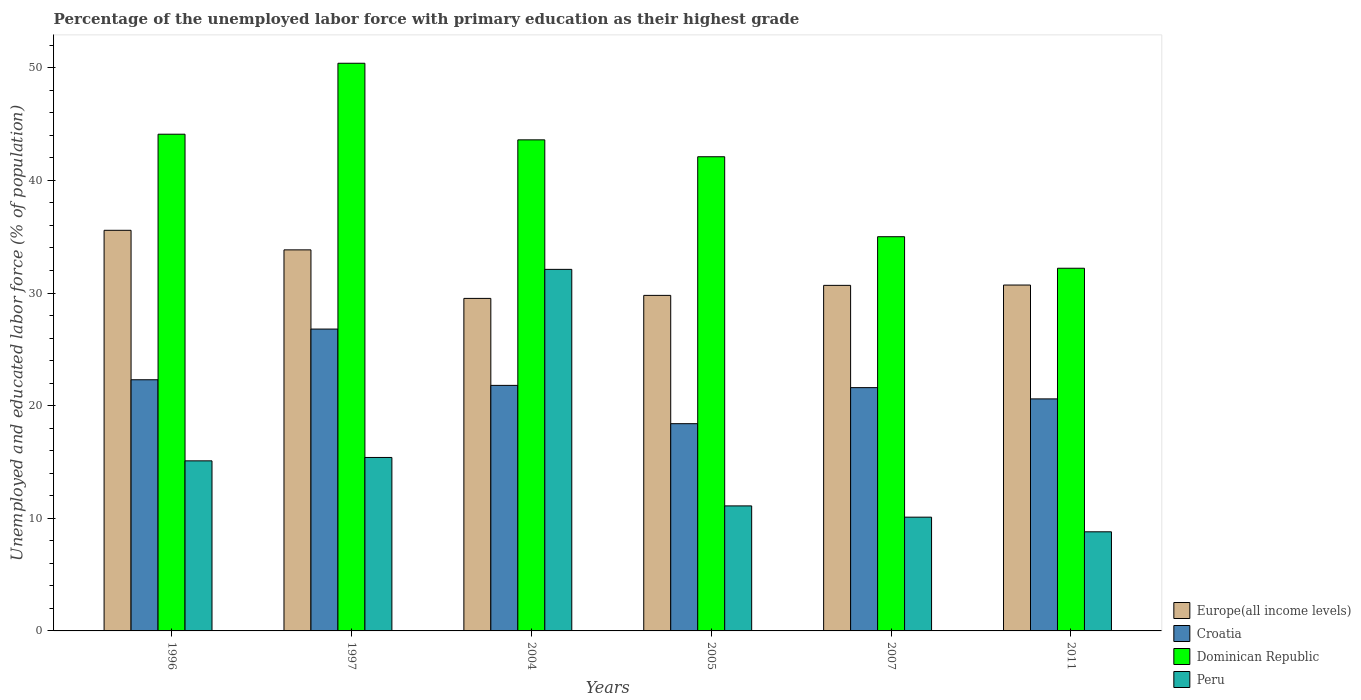How many different coloured bars are there?
Provide a succinct answer. 4. Are the number of bars on each tick of the X-axis equal?
Your response must be concise. Yes. How many bars are there on the 3rd tick from the left?
Your response must be concise. 4. What is the label of the 5th group of bars from the left?
Your answer should be very brief. 2007. Across all years, what is the maximum percentage of the unemployed labor force with primary education in Peru?
Your response must be concise. 32.1. Across all years, what is the minimum percentage of the unemployed labor force with primary education in Dominican Republic?
Provide a short and direct response. 32.2. In which year was the percentage of the unemployed labor force with primary education in Europe(all income levels) minimum?
Provide a succinct answer. 2004. What is the total percentage of the unemployed labor force with primary education in Croatia in the graph?
Your answer should be very brief. 131.5. What is the difference between the percentage of the unemployed labor force with primary education in Croatia in 1996 and that in 1997?
Ensure brevity in your answer.  -4.5. What is the difference between the percentage of the unemployed labor force with primary education in Croatia in 2011 and the percentage of the unemployed labor force with primary education in Peru in 2005?
Provide a succinct answer. 9.5. What is the average percentage of the unemployed labor force with primary education in Peru per year?
Ensure brevity in your answer.  15.43. In the year 1997, what is the difference between the percentage of the unemployed labor force with primary education in Europe(all income levels) and percentage of the unemployed labor force with primary education in Dominican Republic?
Offer a very short reply. -16.57. In how many years, is the percentage of the unemployed labor force with primary education in Europe(all income levels) greater than 30 %?
Offer a terse response. 4. What is the ratio of the percentage of the unemployed labor force with primary education in Europe(all income levels) in 2004 to that in 2005?
Make the answer very short. 0.99. Is the percentage of the unemployed labor force with primary education in Europe(all income levels) in 1996 less than that in 2011?
Provide a short and direct response. No. What is the difference between the highest and the lowest percentage of the unemployed labor force with primary education in Dominican Republic?
Ensure brevity in your answer.  18.2. In how many years, is the percentage of the unemployed labor force with primary education in Europe(all income levels) greater than the average percentage of the unemployed labor force with primary education in Europe(all income levels) taken over all years?
Keep it short and to the point. 2. Is it the case that in every year, the sum of the percentage of the unemployed labor force with primary education in Europe(all income levels) and percentage of the unemployed labor force with primary education in Peru is greater than the sum of percentage of the unemployed labor force with primary education in Croatia and percentage of the unemployed labor force with primary education in Dominican Republic?
Offer a very short reply. No. What does the 1st bar from the left in 2005 represents?
Make the answer very short. Europe(all income levels). What does the 4th bar from the right in 2004 represents?
Offer a terse response. Europe(all income levels). Are all the bars in the graph horizontal?
Keep it short and to the point. No. How many years are there in the graph?
Make the answer very short. 6. Where does the legend appear in the graph?
Your answer should be very brief. Bottom right. How many legend labels are there?
Ensure brevity in your answer.  4. How are the legend labels stacked?
Make the answer very short. Vertical. What is the title of the graph?
Provide a short and direct response. Percentage of the unemployed labor force with primary education as their highest grade. Does "India" appear as one of the legend labels in the graph?
Your response must be concise. No. What is the label or title of the Y-axis?
Your answer should be compact. Unemployed and educated labor force (% of population). What is the Unemployed and educated labor force (% of population) in Europe(all income levels) in 1996?
Offer a very short reply. 35.57. What is the Unemployed and educated labor force (% of population) in Croatia in 1996?
Your response must be concise. 22.3. What is the Unemployed and educated labor force (% of population) of Dominican Republic in 1996?
Provide a succinct answer. 44.1. What is the Unemployed and educated labor force (% of population) in Peru in 1996?
Offer a very short reply. 15.1. What is the Unemployed and educated labor force (% of population) of Europe(all income levels) in 1997?
Provide a short and direct response. 33.83. What is the Unemployed and educated labor force (% of population) in Croatia in 1997?
Your answer should be compact. 26.8. What is the Unemployed and educated labor force (% of population) in Dominican Republic in 1997?
Your answer should be compact. 50.4. What is the Unemployed and educated labor force (% of population) in Peru in 1997?
Make the answer very short. 15.4. What is the Unemployed and educated labor force (% of population) of Europe(all income levels) in 2004?
Offer a terse response. 29.52. What is the Unemployed and educated labor force (% of population) of Croatia in 2004?
Give a very brief answer. 21.8. What is the Unemployed and educated labor force (% of population) of Dominican Republic in 2004?
Provide a succinct answer. 43.6. What is the Unemployed and educated labor force (% of population) of Peru in 2004?
Make the answer very short. 32.1. What is the Unemployed and educated labor force (% of population) in Europe(all income levels) in 2005?
Ensure brevity in your answer.  29.79. What is the Unemployed and educated labor force (% of population) of Croatia in 2005?
Offer a terse response. 18.4. What is the Unemployed and educated labor force (% of population) of Dominican Republic in 2005?
Provide a short and direct response. 42.1. What is the Unemployed and educated labor force (% of population) in Peru in 2005?
Give a very brief answer. 11.1. What is the Unemployed and educated labor force (% of population) in Europe(all income levels) in 2007?
Offer a terse response. 30.68. What is the Unemployed and educated labor force (% of population) of Croatia in 2007?
Keep it short and to the point. 21.6. What is the Unemployed and educated labor force (% of population) in Peru in 2007?
Your answer should be compact. 10.1. What is the Unemployed and educated labor force (% of population) in Europe(all income levels) in 2011?
Offer a very short reply. 30.71. What is the Unemployed and educated labor force (% of population) in Croatia in 2011?
Ensure brevity in your answer.  20.6. What is the Unemployed and educated labor force (% of population) in Dominican Republic in 2011?
Offer a terse response. 32.2. What is the Unemployed and educated labor force (% of population) in Peru in 2011?
Offer a terse response. 8.8. Across all years, what is the maximum Unemployed and educated labor force (% of population) in Europe(all income levels)?
Provide a succinct answer. 35.57. Across all years, what is the maximum Unemployed and educated labor force (% of population) of Croatia?
Your response must be concise. 26.8. Across all years, what is the maximum Unemployed and educated labor force (% of population) in Dominican Republic?
Ensure brevity in your answer.  50.4. Across all years, what is the maximum Unemployed and educated labor force (% of population) in Peru?
Offer a terse response. 32.1. Across all years, what is the minimum Unemployed and educated labor force (% of population) in Europe(all income levels)?
Offer a terse response. 29.52. Across all years, what is the minimum Unemployed and educated labor force (% of population) of Croatia?
Provide a short and direct response. 18.4. Across all years, what is the minimum Unemployed and educated labor force (% of population) of Dominican Republic?
Keep it short and to the point. 32.2. Across all years, what is the minimum Unemployed and educated labor force (% of population) of Peru?
Make the answer very short. 8.8. What is the total Unemployed and educated labor force (% of population) in Europe(all income levels) in the graph?
Offer a very short reply. 190.1. What is the total Unemployed and educated labor force (% of population) in Croatia in the graph?
Provide a succinct answer. 131.5. What is the total Unemployed and educated labor force (% of population) of Dominican Republic in the graph?
Ensure brevity in your answer.  247.4. What is the total Unemployed and educated labor force (% of population) of Peru in the graph?
Ensure brevity in your answer.  92.6. What is the difference between the Unemployed and educated labor force (% of population) in Europe(all income levels) in 1996 and that in 1997?
Give a very brief answer. 1.74. What is the difference between the Unemployed and educated labor force (% of population) in Dominican Republic in 1996 and that in 1997?
Make the answer very short. -6.3. What is the difference between the Unemployed and educated labor force (% of population) of Europe(all income levels) in 1996 and that in 2004?
Your answer should be compact. 6.05. What is the difference between the Unemployed and educated labor force (% of population) in Croatia in 1996 and that in 2004?
Make the answer very short. 0.5. What is the difference between the Unemployed and educated labor force (% of population) of Peru in 1996 and that in 2004?
Your answer should be very brief. -17. What is the difference between the Unemployed and educated labor force (% of population) in Europe(all income levels) in 1996 and that in 2005?
Your response must be concise. 5.78. What is the difference between the Unemployed and educated labor force (% of population) of Dominican Republic in 1996 and that in 2005?
Provide a short and direct response. 2. What is the difference between the Unemployed and educated labor force (% of population) in Peru in 1996 and that in 2005?
Your answer should be very brief. 4. What is the difference between the Unemployed and educated labor force (% of population) of Europe(all income levels) in 1996 and that in 2007?
Your response must be concise. 4.89. What is the difference between the Unemployed and educated labor force (% of population) of Croatia in 1996 and that in 2007?
Make the answer very short. 0.7. What is the difference between the Unemployed and educated labor force (% of population) of Peru in 1996 and that in 2007?
Give a very brief answer. 5. What is the difference between the Unemployed and educated labor force (% of population) in Europe(all income levels) in 1996 and that in 2011?
Your response must be concise. 4.86. What is the difference between the Unemployed and educated labor force (% of population) in Croatia in 1996 and that in 2011?
Offer a very short reply. 1.7. What is the difference between the Unemployed and educated labor force (% of population) of Peru in 1996 and that in 2011?
Offer a terse response. 6.3. What is the difference between the Unemployed and educated labor force (% of population) of Europe(all income levels) in 1997 and that in 2004?
Give a very brief answer. 4.31. What is the difference between the Unemployed and educated labor force (% of population) in Dominican Republic in 1997 and that in 2004?
Keep it short and to the point. 6.8. What is the difference between the Unemployed and educated labor force (% of population) in Peru in 1997 and that in 2004?
Ensure brevity in your answer.  -16.7. What is the difference between the Unemployed and educated labor force (% of population) of Europe(all income levels) in 1997 and that in 2005?
Your answer should be very brief. 4.04. What is the difference between the Unemployed and educated labor force (% of population) of Croatia in 1997 and that in 2005?
Your answer should be compact. 8.4. What is the difference between the Unemployed and educated labor force (% of population) of Peru in 1997 and that in 2005?
Offer a terse response. 4.3. What is the difference between the Unemployed and educated labor force (% of population) in Europe(all income levels) in 1997 and that in 2007?
Ensure brevity in your answer.  3.15. What is the difference between the Unemployed and educated labor force (% of population) in Dominican Republic in 1997 and that in 2007?
Keep it short and to the point. 15.4. What is the difference between the Unemployed and educated labor force (% of population) in Europe(all income levels) in 1997 and that in 2011?
Keep it short and to the point. 3.12. What is the difference between the Unemployed and educated labor force (% of population) of Europe(all income levels) in 2004 and that in 2005?
Your response must be concise. -0.27. What is the difference between the Unemployed and educated labor force (% of population) in Croatia in 2004 and that in 2005?
Your response must be concise. 3.4. What is the difference between the Unemployed and educated labor force (% of population) of Dominican Republic in 2004 and that in 2005?
Give a very brief answer. 1.5. What is the difference between the Unemployed and educated labor force (% of population) in Peru in 2004 and that in 2005?
Make the answer very short. 21. What is the difference between the Unemployed and educated labor force (% of population) in Europe(all income levels) in 2004 and that in 2007?
Your response must be concise. -1.16. What is the difference between the Unemployed and educated labor force (% of population) of Europe(all income levels) in 2004 and that in 2011?
Your answer should be very brief. -1.19. What is the difference between the Unemployed and educated labor force (% of population) of Croatia in 2004 and that in 2011?
Offer a very short reply. 1.2. What is the difference between the Unemployed and educated labor force (% of population) of Peru in 2004 and that in 2011?
Keep it short and to the point. 23.3. What is the difference between the Unemployed and educated labor force (% of population) of Europe(all income levels) in 2005 and that in 2007?
Your response must be concise. -0.89. What is the difference between the Unemployed and educated labor force (% of population) of Peru in 2005 and that in 2007?
Ensure brevity in your answer.  1. What is the difference between the Unemployed and educated labor force (% of population) in Europe(all income levels) in 2005 and that in 2011?
Your response must be concise. -0.92. What is the difference between the Unemployed and educated labor force (% of population) in Croatia in 2005 and that in 2011?
Make the answer very short. -2.2. What is the difference between the Unemployed and educated labor force (% of population) of Dominican Republic in 2005 and that in 2011?
Keep it short and to the point. 9.9. What is the difference between the Unemployed and educated labor force (% of population) of Europe(all income levels) in 2007 and that in 2011?
Provide a short and direct response. -0.03. What is the difference between the Unemployed and educated labor force (% of population) in Croatia in 2007 and that in 2011?
Your answer should be compact. 1. What is the difference between the Unemployed and educated labor force (% of population) in Europe(all income levels) in 1996 and the Unemployed and educated labor force (% of population) in Croatia in 1997?
Keep it short and to the point. 8.77. What is the difference between the Unemployed and educated labor force (% of population) of Europe(all income levels) in 1996 and the Unemployed and educated labor force (% of population) of Dominican Republic in 1997?
Your answer should be compact. -14.83. What is the difference between the Unemployed and educated labor force (% of population) in Europe(all income levels) in 1996 and the Unemployed and educated labor force (% of population) in Peru in 1997?
Your response must be concise. 20.17. What is the difference between the Unemployed and educated labor force (% of population) in Croatia in 1996 and the Unemployed and educated labor force (% of population) in Dominican Republic in 1997?
Your answer should be compact. -28.1. What is the difference between the Unemployed and educated labor force (% of population) in Dominican Republic in 1996 and the Unemployed and educated labor force (% of population) in Peru in 1997?
Offer a very short reply. 28.7. What is the difference between the Unemployed and educated labor force (% of population) of Europe(all income levels) in 1996 and the Unemployed and educated labor force (% of population) of Croatia in 2004?
Your response must be concise. 13.77. What is the difference between the Unemployed and educated labor force (% of population) in Europe(all income levels) in 1996 and the Unemployed and educated labor force (% of population) in Dominican Republic in 2004?
Keep it short and to the point. -8.03. What is the difference between the Unemployed and educated labor force (% of population) of Europe(all income levels) in 1996 and the Unemployed and educated labor force (% of population) of Peru in 2004?
Your answer should be very brief. 3.47. What is the difference between the Unemployed and educated labor force (% of population) in Croatia in 1996 and the Unemployed and educated labor force (% of population) in Dominican Republic in 2004?
Ensure brevity in your answer.  -21.3. What is the difference between the Unemployed and educated labor force (% of population) in Europe(all income levels) in 1996 and the Unemployed and educated labor force (% of population) in Croatia in 2005?
Your answer should be compact. 17.17. What is the difference between the Unemployed and educated labor force (% of population) of Europe(all income levels) in 1996 and the Unemployed and educated labor force (% of population) of Dominican Republic in 2005?
Provide a succinct answer. -6.53. What is the difference between the Unemployed and educated labor force (% of population) of Europe(all income levels) in 1996 and the Unemployed and educated labor force (% of population) of Peru in 2005?
Make the answer very short. 24.47. What is the difference between the Unemployed and educated labor force (% of population) of Croatia in 1996 and the Unemployed and educated labor force (% of population) of Dominican Republic in 2005?
Give a very brief answer. -19.8. What is the difference between the Unemployed and educated labor force (% of population) of Croatia in 1996 and the Unemployed and educated labor force (% of population) of Peru in 2005?
Ensure brevity in your answer.  11.2. What is the difference between the Unemployed and educated labor force (% of population) of Dominican Republic in 1996 and the Unemployed and educated labor force (% of population) of Peru in 2005?
Keep it short and to the point. 33. What is the difference between the Unemployed and educated labor force (% of population) of Europe(all income levels) in 1996 and the Unemployed and educated labor force (% of population) of Croatia in 2007?
Provide a short and direct response. 13.97. What is the difference between the Unemployed and educated labor force (% of population) in Europe(all income levels) in 1996 and the Unemployed and educated labor force (% of population) in Dominican Republic in 2007?
Your response must be concise. 0.57. What is the difference between the Unemployed and educated labor force (% of population) in Europe(all income levels) in 1996 and the Unemployed and educated labor force (% of population) in Peru in 2007?
Keep it short and to the point. 25.47. What is the difference between the Unemployed and educated labor force (% of population) of Croatia in 1996 and the Unemployed and educated labor force (% of population) of Peru in 2007?
Keep it short and to the point. 12.2. What is the difference between the Unemployed and educated labor force (% of population) of Dominican Republic in 1996 and the Unemployed and educated labor force (% of population) of Peru in 2007?
Your response must be concise. 34. What is the difference between the Unemployed and educated labor force (% of population) in Europe(all income levels) in 1996 and the Unemployed and educated labor force (% of population) in Croatia in 2011?
Make the answer very short. 14.97. What is the difference between the Unemployed and educated labor force (% of population) in Europe(all income levels) in 1996 and the Unemployed and educated labor force (% of population) in Dominican Republic in 2011?
Provide a short and direct response. 3.37. What is the difference between the Unemployed and educated labor force (% of population) in Europe(all income levels) in 1996 and the Unemployed and educated labor force (% of population) in Peru in 2011?
Your response must be concise. 26.77. What is the difference between the Unemployed and educated labor force (% of population) in Croatia in 1996 and the Unemployed and educated labor force (% of population) in Dominican Republic in 2011?
Keep it short and to the point. -9.9. What is the difference between the Unemployed and educated labor force (% of population) in Croatia in 1996 and the Unemployed and educated labor force (% of population) in Peru in 2011?
Provide a short and direct response. 13.5. What is the difference between the Unemployed and educated labor force (% of population) in Dominican Republic in 1996 and the Unemployed and educated labor force (% of population) in Peru in 2011?
Give a very brief answer. 35.3. What is the difference between the Unemployed and educated labor force (% of population) in Europe(all income levels) in 1997 and the Unemployed and educated labor force (% of population) in Croatia in 2004?
Provide a succinct answer. 12.03. What is the difference between the Unemployed and educated labor force (% of population) in Europe(all income levels) in 1997 and the Unemployed and educated labor force (% of population) in Dominican Republic in 2004?
Your response must be concise. -9.77. What is the difference between the Unemployed and educated labor force (% of population) in Europe(all income levels) in 1997 and the Unemployed and educated labor force (% of population) in Peru in 2004?
Make the answer very short. 1.73. What is the difference between the Unemployed and educated labor force (% of population) of Croatia in 1997 and the Unemployed and educated labor force (% of population) of Dominican Republic in 2004?
Give a very brief answer. -16.8. What is the difference between the Unemployed and educated labor force (% of population) in Europe(all income levels) in 1997 and the Unemployed and educated labor force (% of population) in Croatia in 2005?
Give a very brief answer. 15.43. What is the difference between the Unemployed and educated labor force (% of population) of Europe(all income levels) in 1997 and the Unemployed and educated labor force (% of population) of Dominican Republic in 2005?
Your response must be concise. -8.27. What is the difference between the Unemployed and educated labor force (% of population) in Europe(all income levels) in 1997 and the Unemployed and educated labor force (% of population) in Peru in 2005?
Give a very brief answer. 22.73. What is the difference between the Unemployed and educated labor force (% of population) of Croatia in 1997 and the Unemployed and educated labor force (% of population) of Dominican Republic in 2005?
Provide a short and direct response. -15.3. What is the difference between the Unemployed and educated labor force (% of population) of Croatia in 1997 and the Unemployed and educated labor force (% of population) of Peru in 2005?
Your answer should be very brief. 15.7. What is the difference between the Unemployed and educated labor force (% of population) in Dominican Republic in 1997 and the Unemployed and educated labor force (% of population) in Peru in 2005?
Your response must be concise. 39.3. What is the difference between the Unemployed and educated labor force (% of population) in Europe(all income levels) in 1997 and the Unemployed and educated labor force (% of population) in Croatia in 2007?
Offer a terse response. 12.23. What is the difference between the Unemployed and educated labor force (% of population) in Europe(all income levels) in 1997 and the Unemployed and educated labor force (% of population) in Dominican Republic in 2007?
Give a very brief answer. -1.17. What is the difference between the Unemployed and educated labor force (% of population) of Europe(all income levels) in 1997 and the Unemployed and educated labor force (% of population) of Peru in 2007?
Keep it short and to the point. 23.73. What is the difference between the Unemployed and educated labor force (% of population) in Dominican Republic in 1997 and the Unemployed and educated labor force (% of population) in Peru in 2007?
Your response must be concise. 40.3. What is the difference between the Unemployed and educated labor force (% of population) of Europe(all income levels) in 1997 and the Unemployed and educated labor force (% of population) of Croatia in 2011?
Your answer should be very brief. 13.23. What is the difference between the Unemployed and educated labor force (% of population) of Europe(all income levels) in 1997 and the Unemployed and educated labor force (% of population) of Dominican Republic in 2011?
Ensure brevity in your answer.  1.63. What is the difference between the Unemployed and educated labor force (% of population) of Europe(all income levels) in 1997 and the Unemployed and educated labor force (% of population) of Peru in 2011?
Provide a succinct answer. 25.03. What is the difference between the Unemployed and educated labor force (% of population) of Croatia in 1997 and the Unemployed and educated labor force (% of population) of Peru in 2011?
Provide a succinct answer. 18. What is the difference between the Unemployed and educated labor force (% of population) in Dominican Republic in 1997 and the Unemployed and educated labor force (% of population) in Peru in 2011?
Keep it short and to the point. 41.6. What is the difference between the Unemployed and educated labor force (% of population) of Europe(all income levels) in 2004 and the Unemployed and educated labor force (% of population) of Croatia in 2005?
Offer a terse response. 11.12. What is the difference between the Unemployed and educated labor force (% of population) of Europe(all income levels) in 2004 and the Unemployed and educated labor force (% of population) of Dominican Republic in 2005?
Your answer should be very brief. -12.58. What is the difference between the Unemployed and educated labor force (% of population) of Europe(all income levels) in 2004 and the Unemployed and educated labor force (% of population) of Peru in 2005?
Offer a terse response. 18.42. What is the difference between the Unemployed and educated labor force (% of population) in Croatia in 2004 and the Unemployed and educated labor force (% of population) in Dominican Republic in 2005?
Ensure brevity in your answer.  -20.3. What is the difference between the Unemployed and educated labor force (% of population) of Croatia in 2004 and the Unemployed and educated labor force (% of population) of Peru in 2005?
Your response must be concise. 10.7. What is the difference between the Unemployed and educated labor force (% of population) in Dominican Republic in 2004 and the Unemployed and educated labor force (% of population) in Peru in 2005?
Offer a terse response. 32.5. What is the difference between the Unemployed and educated labor force (% of population) in Europe(all income levels) in 2004 and the Unemployed and educated labor force (% of population) in Croatia in 2007?
Provide a succinct answer. 7.92. What is the difference between the Unemployed and educated labor force (% of population) in Europe(all income levels) in 2004 and the Unemployed and educated labor force (% of population) in Dominican Republic in 2007?
Your answer should be compact. -5.48. What is the difference between the Unemployed and educated labor force (% of population) in Europe(all income levels) in 2004 and the Unemployed and educated labor force (% of population) in Peru in 2007?
Provide a short and direct response. 19.42. What is the difference between the Unemployed and educated labor force (% of population) of Croatia in 2004 and the Unemployed and educated labor force (% of population) of Dominican Republic in 2007?
Your answer should be compact. -13.2. What is the difference between the Unemployed and educated labor force (% of population) of Croatia in 2004 and the Unemployed and educated labor force (% of population) of Peru in 2007?
Your answer should be compact. 11.7. What is the difference between the Unemployed and educated labor force (% of population) in Dominican Republic in 2004 and the Unemployed and educated labor force (% of population) in Peru in 2007?
Provide a succinct answer. 33.5. What is the difference between the Unemployed and educated labor force (% of population) in Europe(all income levels) in 2004 and the Unemployed and educated labor force (% of population) in Croatia in 2011?
Offer a terse response. 8.92. What is the difference between the Unemployed and educated labor force (% of population) in Europe(all income levels) in 2004 and the Unemployed and educated labor force (% of population) in Dominican Republic in 2011?
Provide a succinct answer. -2.68. What is the difference between the Unemployed and educated labor force (% of population) of Europe(all income levels) in 2004 and the Unemployed and educated labor force (% of population) of Peru in 2011?
Ensure brevity in your answer.  20.72. What is the difference between the Unemployed and educated labor force (% of population) in Croatia in 2004 and the Unemployed and educated labor force (% of population) in Dominican Republic in 2011?
Your response must be concise. -10.4. What is the difference between the Unemployed and educated labor force (% of population) of Croatia in 2004 and the Unemployed and educated labor force (% of population) of Peru in 2011?
Your response must be concise. 13. What is the difference between the Unemployed and educated labor force (% of population) in Dominican Republic in 2004 and the Unemployed and educated labor force (% of population) in Peru in 2011?
Make the answer very short. 34.8. What is the difference between the Unemployed and educated labor force (% of population) in Europe(all income levels) in 2005 and the Unemployed and educated labor force (% of population) in Croatia in 2007?
Your response must be concise. 8.19. What is the difference between the Unemployed and educated labor force (% of population) in Europe(all income levels) in 2005 and the Unemployed and educated labor force (% of population) in Dominican Republic in 2007?
Provide a succinct answer. -5.21. What is the difference between the Unemployed and educated labor force (% of population) of Europe(all income levels) in 2005 and the Unemployed and educated labor force (% of population) of Peru in 2007?
Provide a short and direct response. 19.69. What is the difference between the Unemployed and educated labor force (% of population) in Croatia in 2005 and the Unemployed and educated labor force (% of population) in Dominican Republic in 2007?
Offer a very short reply. -16.6. What is the difference between the Unemployed and educated labor force (% of population) of Croatia in 2005 and the Unemployed and educated labor force (% of population) of Peru in 2007?
Your answer should be compact. 8.3. What is the difference between the Unemployed and educated labor force (% of population) in Dominican Republic in 2005 and the Unemployed and educated labor force (% of population) in Peru in 2007?
Offer a terse response. 32. What is the difference between the Unemployed and educated labor force (% of population) in Europe(all income levels) in 2005 and the Unemployed and educated labor force (% of population) in Croatia in 2011?
Keep it short and to the point. 9.19. What is the difference between the Unemployed and educated labor force (% of population) in Europe(all income levels) in 2005 and the Unemployed and educated labor force (% of population) in Dominican Republic in 2011?
Your answer should be compact. -2.41. What is the difference between the Unemployed and educated labor force (% of population) in Europe(all income levels) in 2005 and the Unemployed and educated labor force (% of population) in Peru in 2011?
Give a very brief answer. 20.99. What is the difference between the Unemployed and educated labor force (% of population) of Croatia in 2005 and the Unemployed and educated labor force (% of population) of Dominican Republic in 2011?
Provide a succinct answer. -13.8. What is the difference between the Unemployed and educated labor force (% of population) of Croatia in 2005 and the Unemployed and educated labor force (% of population) of Peru in 2011?
Your response must be concise. 9.6. What is the difference between the Unemployed and educated labor force (% of population) in Dominican Republic in 2005 and the Unemployed and educated labor force (% of population) in Peru in 2011?
Provide a short and direct response. 33.3. What is the difference between the Unemployed and educated labor force (% of population) in Europe(all income levels) in 2007 and the Unemployed and educated labor force (% of population) in Croatia in 2011?
Your response must be concise. 10.08. What is the difference between the Unemployed and educated labor force (% of population) in Europe(all income levels) in 2007 and the Unemployed and educated labor force (% of population) in Dominican Republic in 2011?
Your response must be concise. -1.52. What is the difference between the Unemployed and educated labor force (% of population) in Europe(all income levels) in 2007 and the Unemployed and educated labor force (% of population) in Peru in 2011?
Make the answer very short. 21.88. What is the difference between the Unemployed and educated labor force (% of population) in Croatia in 2007 and the Unemployed and educated labor force (% of population) in Peru in 2011?
Give a very brief answer. 12.8. What is the difference between the Unemployed and educated labor force (% of population) in Dominican Republic in 2007 and the Unemployed and educated labor force (% of population) in Peru in 2011?
Ensure brevity in your answer.  26.2. What is the average Unemployed and educated labor force (% of population) in Europe(all income levels) per year?
Your answer should be very brief. 31.68. What is the average Unemployed and educated labor force (% of population) in Croatia per year?
Your answer should be compact. 21.92. What is the average Unemployed and educated labor force (% of population) in Dominican Republic per year?
Your answer should be very brief. 41.23. What is the average Unemployed and educated labor force (% of population) in Peru per year?
Ensure brevity in your answer.  15.43. In the year 1996, what is the difference between the Unemployed and educated labor force (% of population) in Europe(all income levels) and Unemployed and educated labor force (% of population) in Croatia?
Your answer should be very brief. 13.27. In the year 1996, what is the difference between the Unemployed and educated labor force (% of population) in Europe(all income levels) and Unemployed and educated labor force (% of population) in Dominican Republic?
Make the answer very short. -8.53. In the year 1996, what is the difference between the Unemployed and educated labor force (% of population) in Europe(all income levels) and Unemployed and educated labor force (% of population) in Peru?
Provide a short and direct response. 20.47. In the year 1996, what is the difference between the Unemployed and educated labor force (% of population) of Croatia and Unemployed and educated labor force (% of population) of Dominican Republic?
Make the answer very short. -21.8. In the year 1996, what is the difference between the Unemployed and educated labor force (% of population) of Dominican Republic and Unemployed and educated labor force (% of population) of Peru?
Ensure brevity in your answer.  29. In the year 1997, what is the difference between the Unemployed and educated labor force (% of population) in Europe(all income levels) and Unemployed and educated labor force (% of population) in Croatia?
Your answer should be compact. 7.03. In the year 1997, what is the difference between the Unemployed and educated labor force (% of population) of Europe(all income levels) and Unemployed and educated labor force (% of population) of Dominican Republic?
Your answer should be very brief. -16.57. In the year 1997, what is the difference between the Unemployed and educated labor force (% of population) in Europe(all income levels) and Unemployed and educated labor force (% of population) in Peru?
Provide a short and direct response. 18.43. In the year 1997, what is the difference between the Unemployed and educated labor force (% of population) of Croatia and Unemployed and educated labor force (% of population) of Dominican Republic?
Ensure brevity in your answer.  -23.6. In the year 1997, what is the difference between the Unemployed and educated labor force (% of population) in Croatia and Unemployed and educated labor force (% of population) in Peru?
Your response must be concise. 11.4. In the year 1997, what is the difference between the Unemployed and educated labor force (% of population) in Dominican Republic and Unemployed and educated labor force (% of population) in Peru?
Your answer should be very brief. 35. In the year 2004, what is the difference between the Unemployed and educated labor force (% of population) of Europe(all income levels) and Unemployed and educated labor force (% of population) of Croatia?
Make the answer very short. 7.72. In the year 2004, what is the difference between the Unemployed and educated labor force (% of population) of Europe(all income levels) and Unemployed and educated labor force (% of population) of Dominican Republic?
Your response must be concise. -14.08. In the year 2004, what is the difference between the Unemployed and educated labor force (% of population) in Europe(all income levels) and Unemployed and educated labor force (% of population) in Peru?
Ensure brevity in your answer.  -2.58. In the year 2004, what is the difference between the Unemployed and educated labor force (% of population) of Croatia and Unemployed and educated labor force (% of population) of Dominican Republic?
Your answer should be very brief. -21.8. In the year 2004, what is the difference between the Unemployed and educated labor force (% of population) in Croatia and Unemployed and educated labor force (% of population) in Peru?
Keep it short and to the point. -10.3. In the year 2004, what is the difference between the Unemployed and educated labor force (% of population) in Dominican Republic and Unemployed and educated labor force (% of population) in Peru?
Offer a very short reply. 11.5. In the year 2005, what is the difference between the Unemployed and educated labor force (% of population) in Europe(all income levels) and Unemployed and educated labor force (% of population) in Croatia?
Keep it short and to the point. 11.39. In the year 2005, what is the difference between the Unemployed and educated labor force (% of population) of Europe(all income levels) and Unemployed and educated labor force (% of population) of Dominican Republic?
Make the answer very short. -12.31. In the year 2005, what is the difference between the Unemployed and educated labor force (% of population) in Europe(all income levels) and Unemployed and educated labor force (% of population) in Peru?
Offer a terse response. 18.69. In the year 2005, what is the difference between the Unemployed and educated labor force (% of population) of Croatia and Unemployed and educated labor force (% of population) of Dominican Republic?
Ensure brevity in your answer.  -23.7. In the year 2005, what is the difference between the Unemployed and educated labor force (% of population) of Croatia and Unemployed and educated labor force (% of population) of Peru?
Give a very brief answer. 7.3. In the year 2007, what is the difference between the Unemployed and educated labor force (% of population) of Europe(all income levels) and Unemployed and educated labor force (% of population) of Croatia?
Offer a very short reply. 9.08. In the year 2007, what is the difference between the Unemployed and educated labor force (% of population) of Europe(all income levels) and Unemployed and educated labor force (% of population) of Dominican Republic?
Ensure brevity in your answer.  -4.32. In the year 2007, what is the difference between the Unemployed and educated labor force (% of population) in Europe(all income levels) and Unemployed and educated labor force (% of population) in Peru?
Offer a very short reply. 20.58. In the year 2007, what is the difference between the Unemployed and educated labor force (% of population) in Croatia and Unemployed and educated labor force (% of population) in Peru?
Provide a short and direct response. 11.5. In the year 2007, what is the difference between the Unemployed and educated labor force (% of population) of Dominican Republic and Unemployed and educated labor force (% of population) of Peru?
Your response must be concise. 24.9. In the year 2011, what is the difference between the Unemployed and educated labor force (% of population) of Europe(all income levels) and Unemployed and educated labor force (% of population) of Croatia?
Make the answer very short. 10.11. In the year 2011, what is the difference between the Unemployed and educated labor force (% of population) in Europe(all income levels) and Unemployed and educated labor force (% of population) in Dominican Republic?
Make the answer very short. -1.49. In the year 2011, what is the difference between the Unemployed and educated labor force (% of population) in Europe(all income levels) and Unemployed and educated labor force (% of population) in Peru?
Keep it short and to the point. 21.91. In the year 2011, what is the difference between the Unemployed and educated labor force (% of population) of Croatia and Unemployed and educated labor force (% of population) of Dominican Republic?
Provide a succinct answer. -11.6. In the year 2011, what is the difference between the Unemployed and educated labor force (% of population) of Croatia and Unemployed and educated labor force (% of population) of Peru?
Give a very brief answer. 11.8. In the year 2011, what is the difference between the Unemployed and educated labor force (% of population) of Dominican Republic and Unemployed and educated labor force (% of population) of Peru?
Your answer should be very brief. 23.4. What is the ratio of the Unemployed and educated labor force (% of population) of Europe(all income levels) in 1996 to that in 1997?
Your answer should be very brief. 1.05. What is the ratio of the Unemployed and educated labor force (% of population) of Croatia in 1996 to that in 1997?
Your answer should be very brief. 0.83. What is the ratio of the Unemployed and educated labor force (% of population) of Dominican Republic in 1996 to that in 1997?
Offer a terse response. 0.88. What is the ratio of the Unemployed and educated labor force (% of population) of Peru in 1996 to that in 1997?
Provide a succinct answer. 0.98. What is the ratio of the Unemployed and educated labor force (% of population) in Europe(all income levels) in 1996 to that in 2004?
Your answer should be compact. 1.2. What is the ratio of the Unemployed and educated labor force (% of population) in Croatia in 1996 to that in 2004?
Provide a short and direct response. 1.02. What is the ratio of the Unemployed and educated labor force (% of population) of Dominican Republic in 1996 to that in 2004?
Provide a short and direct response. 1.01. What is the ratio of the Unemployed and educated labor force (% of population) of Peru in 1996 to that in 2004?
Offer a terse response. 0.47. What is the ratio of the Unemployed and educated labor force (% of population) in Europe(all income levels) in 1996 to that in 2005?
Offer a very short reply. 1.19. What is the ratio of the Unemployed and educated labor force (% of population) of Croatia in 1996 to that in 2005?
Provide a short and direct response. 1.21. What is the ratio of the Unemployed and educated labor force (% of population) in Dominican Republic in 1996 to that in 2005?
Provide a succinct answer. 1.05. What is the ratio of the Unemployed and educated labor force (% of population) of Peru in 1996 to that in 2005?
Provide a succinct answer. 1.36. What is the ratio of the Unemployed and educated labor force (% of population) in Europe(all income levels) in 1996 to that in 2007?
Your response must be concise. 1.16. What is the ratio of the Unemployed and educated labor force (% of population) in Croatia in 1996 to that in 2007?
Keep it short and to the point. 1.03. What is the ratio of the Unemployed and educated labor force (% of population) in Dominican Republic in 1996 to that in 2007?
Your answer should be compact. 1.26. What is the ratio of the Unemployed and educated labor force (% of population) of Peru in 1996 to that in 2007?
Keep it short and to the point. 1.5. What is the ratio of the Unemployed and educated labor force (% of population) in Europe(all income levels) in 1996 to that in 2011?
Offer a terse response. 1.16. What is the ratio of the Unemployed and educated labor force (% of population) in Croatia in 1996 to that in 2011?
Provide a short and direct response. 1.08. What is the ratio of the Unemployed and educated labor force (% of population) of Dominican Republic in 1996 to that in 2011?
Make the answer very short. 1.37. What is the ratio of the Unemployed and educated labor force (% of population) of Peru in 1996 to that in 2011?
Keep it short and to the point. 1.72. What is the ratio of the Unemployed and educated labor force (% of population) of Europe(all income levels) in 1997 to that in 2004?
Your answer should be compact. 1.15. What is the ratio of the Unemployed and educated labor force (% of population) in Croatia in 1997 to that in 2004?
Keep it short and to the point. 1.23. What is the ratio of the Unemployed and educated labor force (% of population) of Dominican Republic in 1997 to that in 2004?
Offer a very short reply. 1.16. What is the ratio of the Unemployed and educated labor force (% of population) in Peru in 1997 to that in 2004?
Make the answer very short. 0.48. What is the ratio of the Unemployed and educated labor force (% of population) in Europe(all income levels) in 1997 to that in 2005?
Give a very brief answer. 1.14. What is the ratio of the Unemployed and educated labor force (% of population) of Croatia in 1997 to that in 2005?
Offer a very short reply. 1.46. What is the ratio of the Unemployed and educated labor force (% of population) of Dominican Republic in 1997 to that in 2005?
Offer a very short reply. 1.2. What is the ratio of the Unemployed and educated labor force (% of population) of Peru in 1997 to that in 2005?
Your answer should be very brief. 1.39. What is the ratio of the Unemployed and educated labor force (% of population) in Europe(all income levels) in 1997 to that in 2007?
Give a very brief answer. 1.1. What is the ratio of the Unemployed and educated labor force (% of population) of Croatia in 1997 to that in 2007?
Ensure brevity in your answer.  1.24. What is the ratio of the Unemployed and educated labor force (% of population) in Dominican Republic in 1997 to that in 2007?
Your answer should be very brief. 1.44. What is the ratio of the Unemployed and educated labor force (% of population) of Peru in 1997 to that in 2007?
Keep it short and to the point. 1.52. What is the ratio of the Unemployed and educated labor force (% of population) in Europe(all income levels) in 1997 to that in 2011?
Offer a very short reply. 1.1. What is the ratio of the Unemployed and educated labor force (% of population) in Croatia in 1997 to that in 2011?
Your response must be concise. 1.3. What is the ratio of the Unemployed and educated labor force (% of population) of Dominican Republic in 1997 to that in 2011?
Ensure brevity in your answer.  1.57. What is the ratio of the Unemployed and educated labor force (% of population) in Europe(all income levels) in 2004 to that in 2005?
Your answer should be compact. 0.99. What is the ratio of the Unemployed and educated labor force (% of population) of Croatia in 2004 to that in 2005?
Give a very brief answer. 1.18. What is the ratio of the Unemployed and educated labor force (% of population) of Dominican Republic in 2004 to that in 2005?
Make the answer very short. 1.04. What is the ratio of the Unemployed and educated labor force (% of population) of Peru in 2004 to that in 2005?
Keep it short and to the point. 2.89. What is the ratio of the Unemployed and educated labor force (% of population) of Europe(all income levels) in 2004 to that in 2007?
Keep it short and to the point. 0.96. What is the ratio of the Unemployed and educated labor force (% of population) of Croatia in 2004 to that in 2007?
Your response must be concise. 1.01. What is the ratio of the Unemployed and educated labor force (% of population) of Dominican Republic in 2004 to that in 2007?
Make the answer very short. 1.25. What is the ratio of the Unemployed and educated labor force (% of population) in Peru in 2004 to that in 2007?
Give a very brief answer. 3.18. What is the ratio of the Unemployed and educated labor force (% of population) of Europe(all income levels) in 2004 to that in 2011?
Provide a short and direct response. 0.96. What is the ratio of the Unemployed and educated labor force (% of population) in Croatia in 2004 to that in 2011?
Offer a very short reply. 1.06. What is the ratio of the Unemployed and educated labor force (% of population) in Dominican Republic in 2004 to that in 2011?
Offer a very short reply. 1.35. What is the ratio of the Unemployed and educated labor force (% of population) of Peru in 2004 to that in 2011?
Ensure brevity in your answer.  3.65. What is the ratio of the Unemployed and educated labor force (% of population) of Croatia in 2005 to that in 2007?
Provide a short and direct response. 0.85. What is the ratio of the Unemployed and educated labor force (% of population) of Dominican Republic in 2005 to that in 2007?
Your response must be concise. 1.2. What is the ratio of the Unemployed and educated labor force (% of population) in Peru in 2005 to that in 2007?
Keep it short and to the point. 1.1. What is the ratio of the Unemployed and educated labor force (% of population) of Europe(all income levels) in 2005 to that in 2011?
Keep it short and to the point. 0.97. What is the ratio of the Unemployed and educated labor force (% of population) of Croatia in 2005 to that in 2011?
Give a very brief answer. 0.89. What is the ratio of the Unemployed and educated labor force (% of population) of Dominican Republic in 2005 to that in 2011?
Make the answer very short. 1.31. What is the ratio of the Unemployed and educated labor force (% of population) in Peru in 2005 to that in 2011?
Offer a very short reply. 1.26. What is the ratio of the Unemployed and educated labor force (% of population) of Europe(all income levels) in 2007 to that in 2011?
Give a very brief answer. 1. What is the ratio of the Unemployed and educated labor force (% of population) of Croatia in 2007 to that in 2011?
Keep it short and to the point. 1.05. What is the ratio of the Unemployed and educated labor force (% of population) in Dominican Republic in 2007 to that in 2011?
Ensure brevity in your answer.  1.09. What is the ratio of the Unemployed and educated labor force (% of population) of Peru in 2007 to that in 2011?
Make the answer very short. 1.15. What is the difference between the highest and the second highest Unemployed and educated labor force (% of population) of Europe(all income levels)?
Ensure brevity in your answer.  1.74. What is the difference between the highest and the second highest Unemployed and educated labor force (% of population) of Dominican Republic?
Your answer should be very brief. 6.3. What is the difference between the highest and the second highest Unemployed and educated labor force (% of population) in Peru?
Provide a succinct answer. 16.7. What is the difference between the highest and the lowest Unemployed and educated labor force (% of population) in Europe(all income levels)?
Make the answer very short. 6.05. What is the difference between the highest and the lowest Unemployed and educated labor force (% of population) of Peru?
Your answer should be very brief. 23.3. 